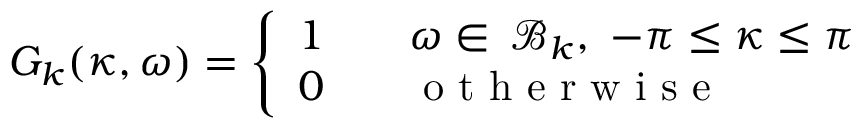Convert formula to latex. <formula><loc_0><loc_0><loc_500><loc_500>G _ { k } ( \kappa , \omega ) = \left \{ \begin{array} { l l } { 1 \quad } & { \omega \in \, \mathcal { B } _ { k } , \ - \pi \leq \kappa \leq \pi } \\ { 0 \ \ } & { o t h e r w i s e } \end{array}</formula> 